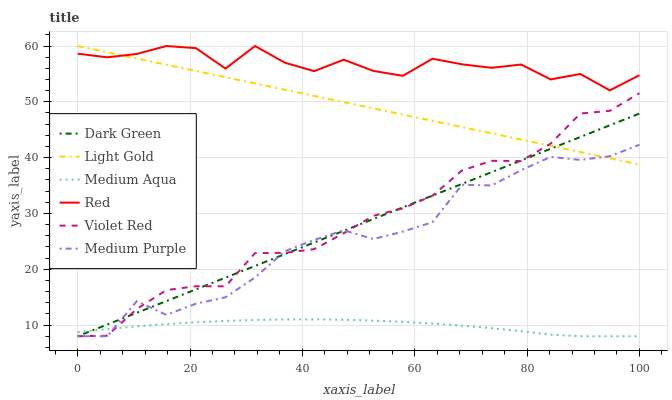Does Medium Aqua have the minimum area under the curve?
Answer yes or no. Yes. Does Red have the maximum area under the curve?
Answer yes or no. Yes. Does Medium Purple have the minimum area under the curve?
Answer yes or no. No. Does Medium Purple have the maximum area under the curve?
Answer yes or no. No. Is Light Gold the smoothest?
Answer yes or no. Yes. Is Red the roughest?
Answer yes or no. Yes. Is Medium Purple the smoothest?
Answer yes or no. No. Is Medium Purple the roughest?
Answer yes or no. No. Does Violet Red have the lowest value?
Answer yes or no. Yes. Does Light Gold have the lowest value?
Answer yes or no. No. Does Red have the highest value?
Answer yes or no. Yes. Does Medium Purple have the highest value?
Answer yes or no. No. Is Violet Red less than Red?
Answer yes or no. Yes. Is Red greater than Medium Aqua?
Answer yes or no. Yes. Does Medium Purple intersect Violet Red?
Answer yes or no. Yes. Is Medium Purple less than Violet Red?
Answer yes or no. No. Is Medium Purple greater than Violet Red?
Answer yes or no. No. Does Violet Red intersect Red?
Answer yes or no. No. 